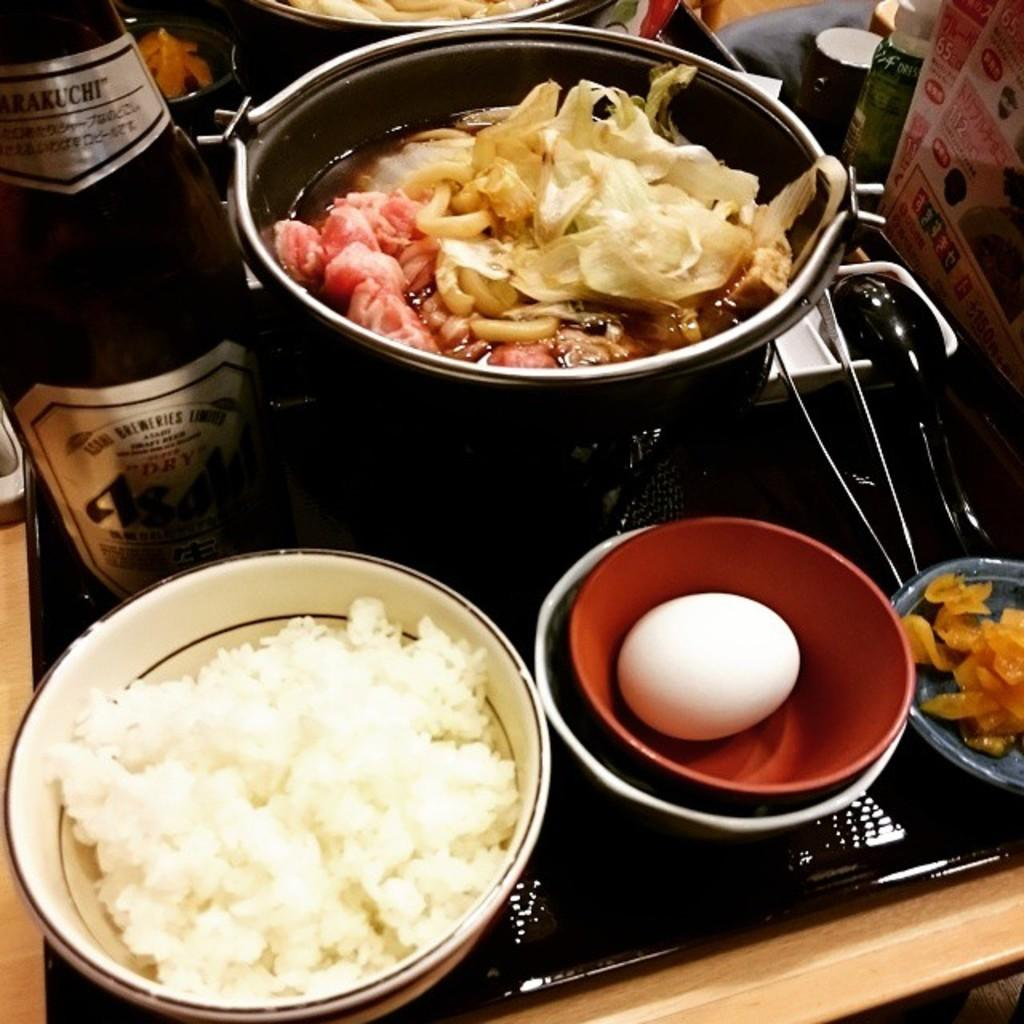<image>
Render a clear and concise summary of the photo. A tray full of food and a beer bottle that says Dry. 